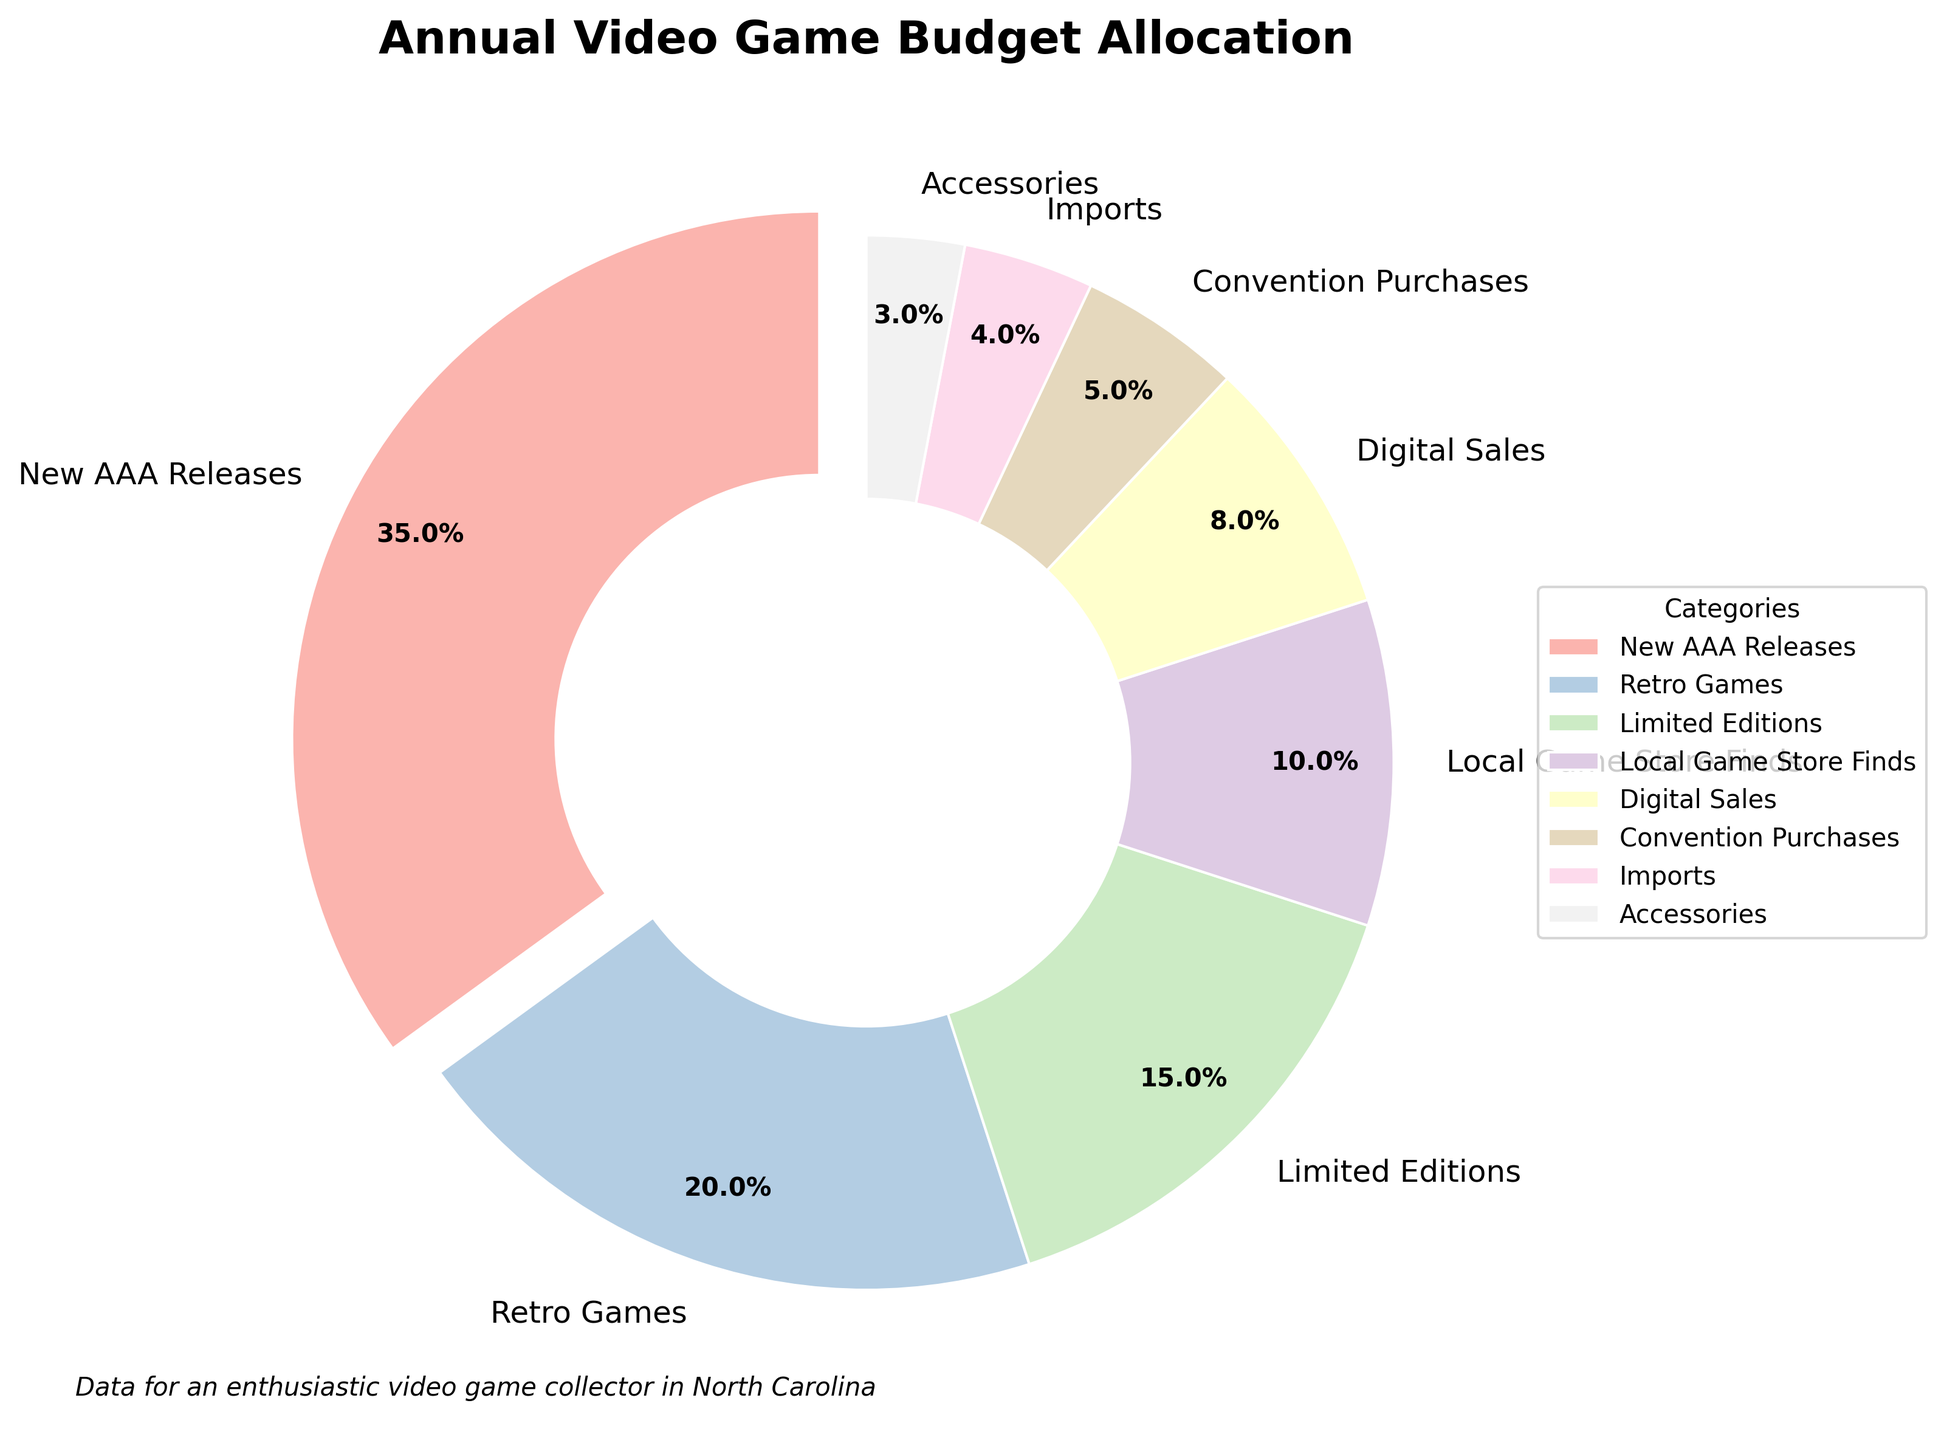What category gets the largest portion of the budget? The largest portion of the budget is for the category with the highest percentage. Reading from the figure, "New AAA Releases" has the highest allocation at 35%.
Answer: New AAA Releases Which categories together take up exactly 30% of the budget? Adding the percentages of different categories until the sum equals 30%. "Digital Sales" (8%) + "Local Game Store Finds" (10%) + "Limited Editions" (15%) can be combined: 8% + 10% + 15% = 33%. However, "Local Game Store Finds" (10%) + "Limited Editions" (15%) + "Accessories" (3%) = 18% + 10% + 3% = 28%, which is closest but still not exact. Checking smaller combinations, "Local Game Store Finds" and "Digital Sales" fit better.
Answer: Local Game Store Finds and Digital Sales How much more is allocated to "New AAA Releases" compared to "Limited Editions"? Subtract the percentage of "Limited Editions" from "New AAA Releases": 35% - 15% = 20%.
Answer: 20% Which category has the second smallest allocation? Reading the percentages and finding the second smallest. "Accessories" is the smallest at 3%, and "Imports" is next with 4%.
Answer: Imports What is the combined percentage of the smallest three allocations? Summing the three smallest percentages. "Accessories" (3%) + "Imports" (4%) + "Convention Purchases" (5%) = 3% + 4% + 5% = 12%.
Answer: 12% Which two categories, when combined, take up more budget than “Retro Games”? "Retro Games" has a 20% allocation. We need two categories that sum to more than 20%. "Limited Editions" (15%) and "Local Game Store Finds" (10%) sum up to more than 20%: 15% + 10% = 25%.
Answer: Limited Editions and Local Game Store Finds What color is used to represent "Convention Purchases"? Identifying the visual color used in the pie chart, which is light brown in a pastel scheme.
Answer: Light brown 